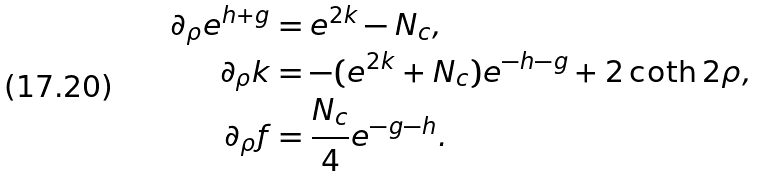<formula> <loc_0><loc_0><loc_500><loc_500>\partial _ { \rho } e ^ { h + g } & = e ^ { 2 k } - N _ { c } , \\ \partial _ { \rho } k & = - ( e ^ { 2 k } + N _ { c } ) e ^ { - h - g } + 2 \coth 2 \rho , \\ \partial _ { \rho } f & = \frac { N _ { c } } { 4 } e ^ { - g - h } .</formula> 